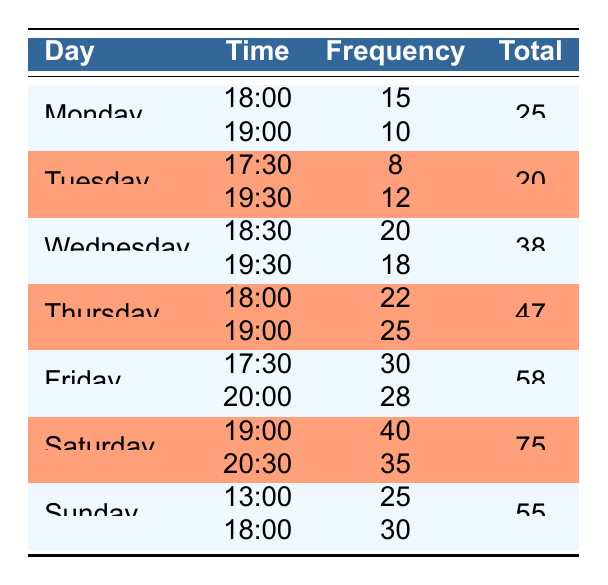What is the most popular reservation time on Saturday? The table lists two reservation times for Saturday: 19:00 with a frequency of 40 and 20:30 with a frequency of 35. The time with the highest frequency is 19:00 with 40 reservations.
Answer: 19:00 How many reservations were made on Friday? There are two reservation times on Friday: 17:30 with a frequency of 30 and 20:00 with a frequency of 28. To find the total, we add these frequencies: 30 + 28 = 58.
Answer: 58 Is the reservation frequency for 18:00 on Sunday greater than that on Monday? The frequency for Sunday at 18:00 is 30, and for Monday at 18:00, it is 15. Since 30 is greater than 15, the statement is true.
Answer: Yes What is the average reservation frequency for Tuesday? Tuesday has two reservation times: 17:30 with a frequency of 8 and 19:30 with a frequency of 12. To find the average, we sum the frequencies (8 + 12 = 20) and divide by the number of time slots (2): 20 / 2 = 10.
Answer: 10 Which day has the highest total reservation frequency? The table shows total frequencies for each day: Monday 25, Tuesday 20, Wednesday 38, Thursday 47, Friday 58, Saturday 75, and Sunday 55. The highest is Saturday with 75.
Answer: Saturday How many more reservations were made at 20:00 on Friday compared to 20:30 on Saturday? There were 28 reservations at 20:00 on Friday and 35 at 20:30 on Saturday. To find the difference: 28 - 35 = -7, indicating 7 more reservations were made at 20:30 on Saturday as opposed to 20:00 on Friday.
Answer: 7 What percentage of the total reservations on Wednesday were made at 19:30? For Wednesday, the total frequency is 38, with 18 reservations at 19:30. The percentage is calculated as (18 / 38) * 100 ≈ 47.37%.
Answer: 47.37% Are there any reservation times with a frequency of 35 or more? Looking at the frequencies, we find 40 at 19:00 on Saturday, 35 at 20:30 on Saturday, 30 at 18:00 on Sunday, and 30 at 17:30 on Friday. Therefore, there are multiple times meeting this criterion.
Answer: Yes 